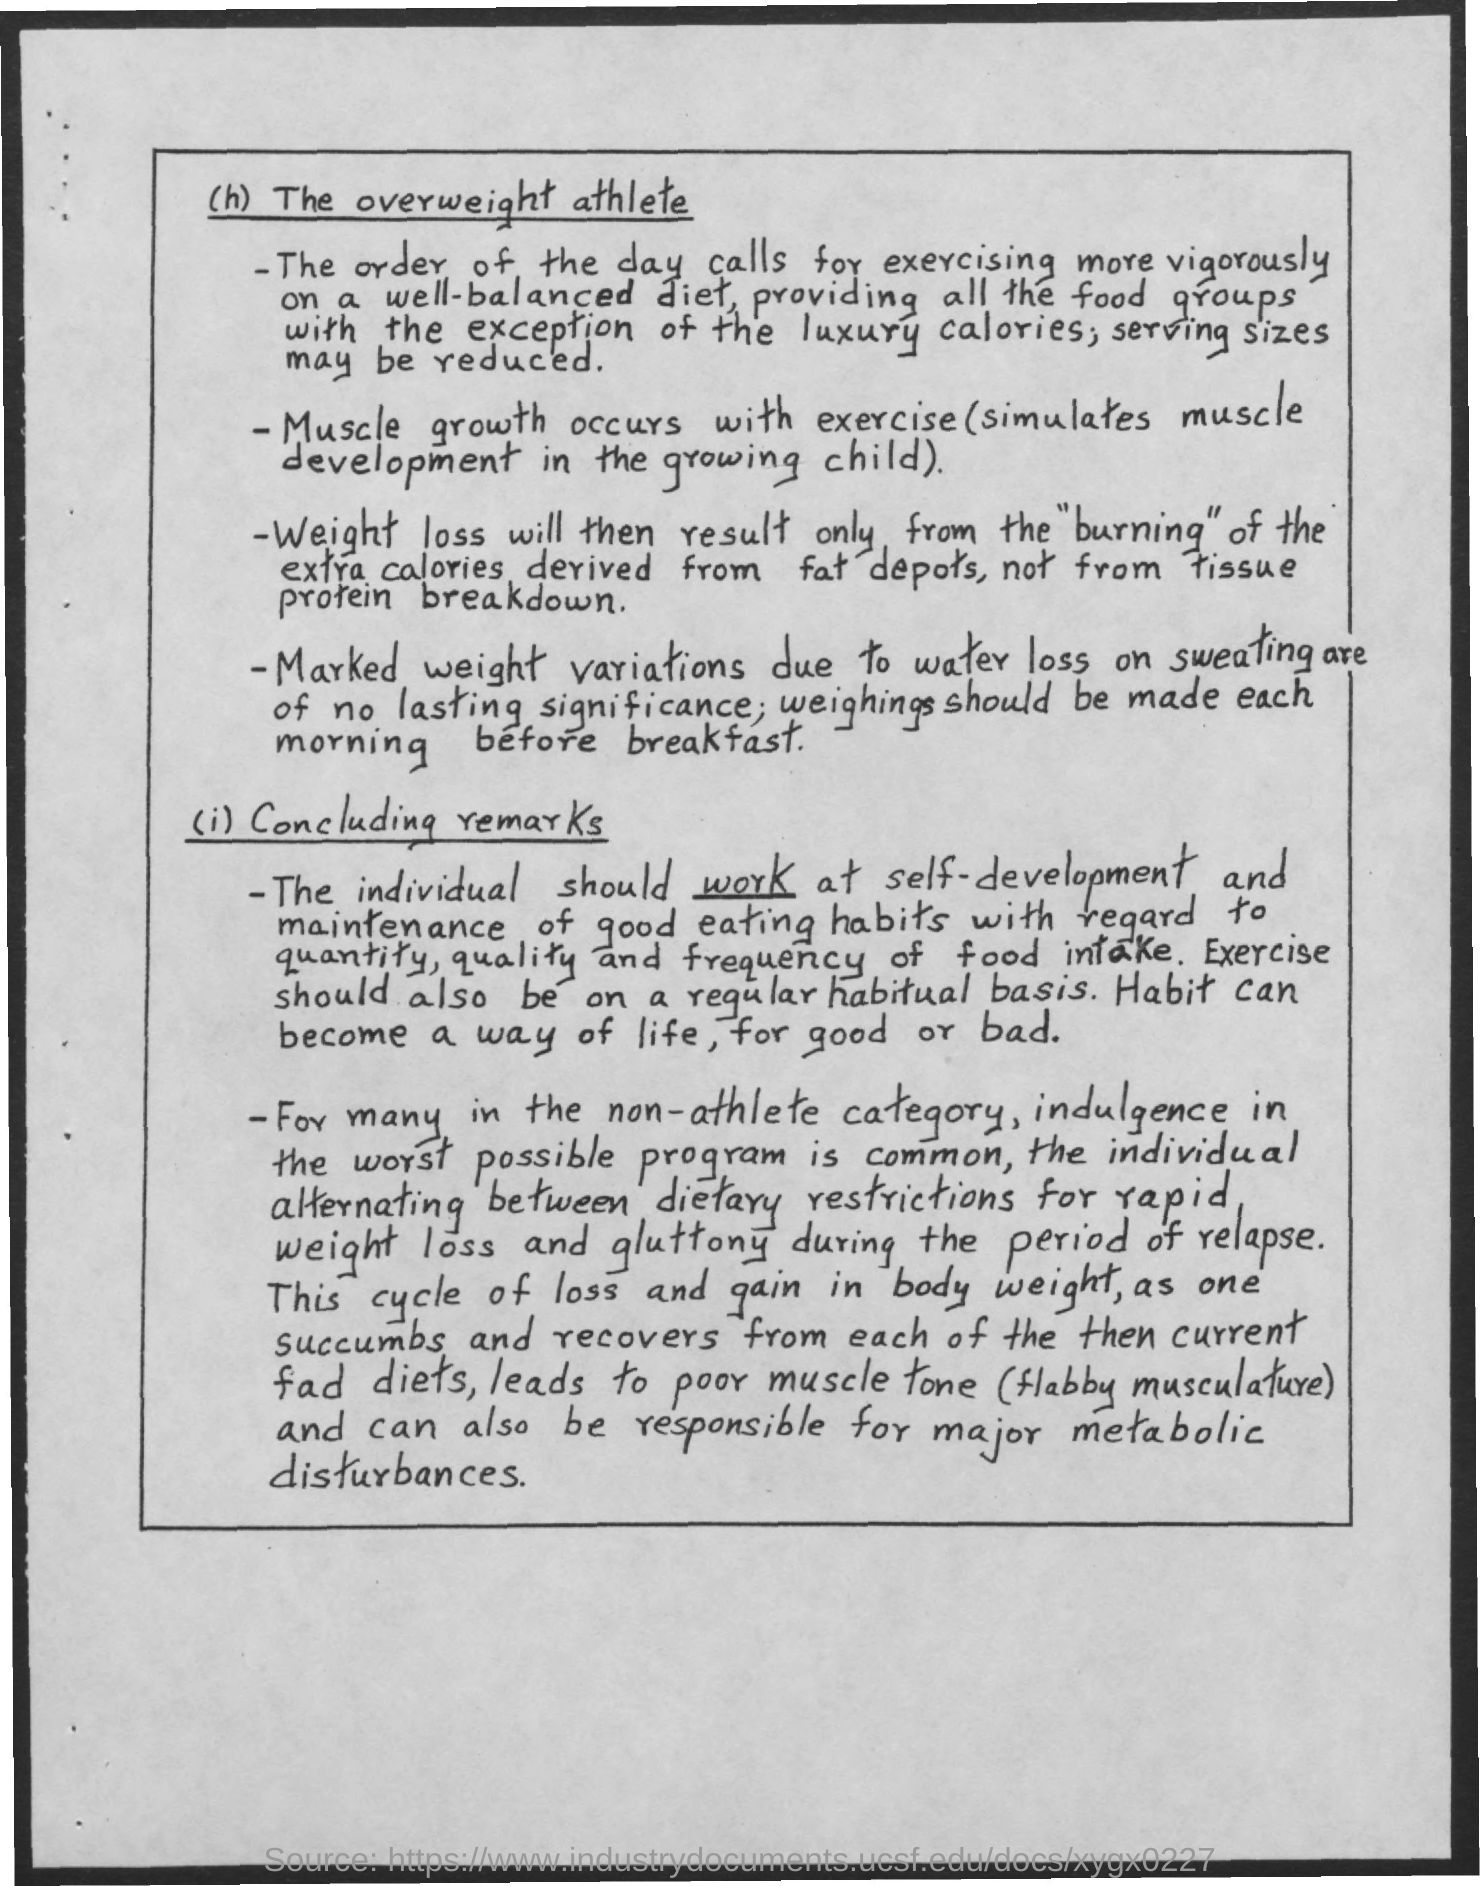What should be done on a regular habitual basis?
Provide a short and direct response. Exercise. 